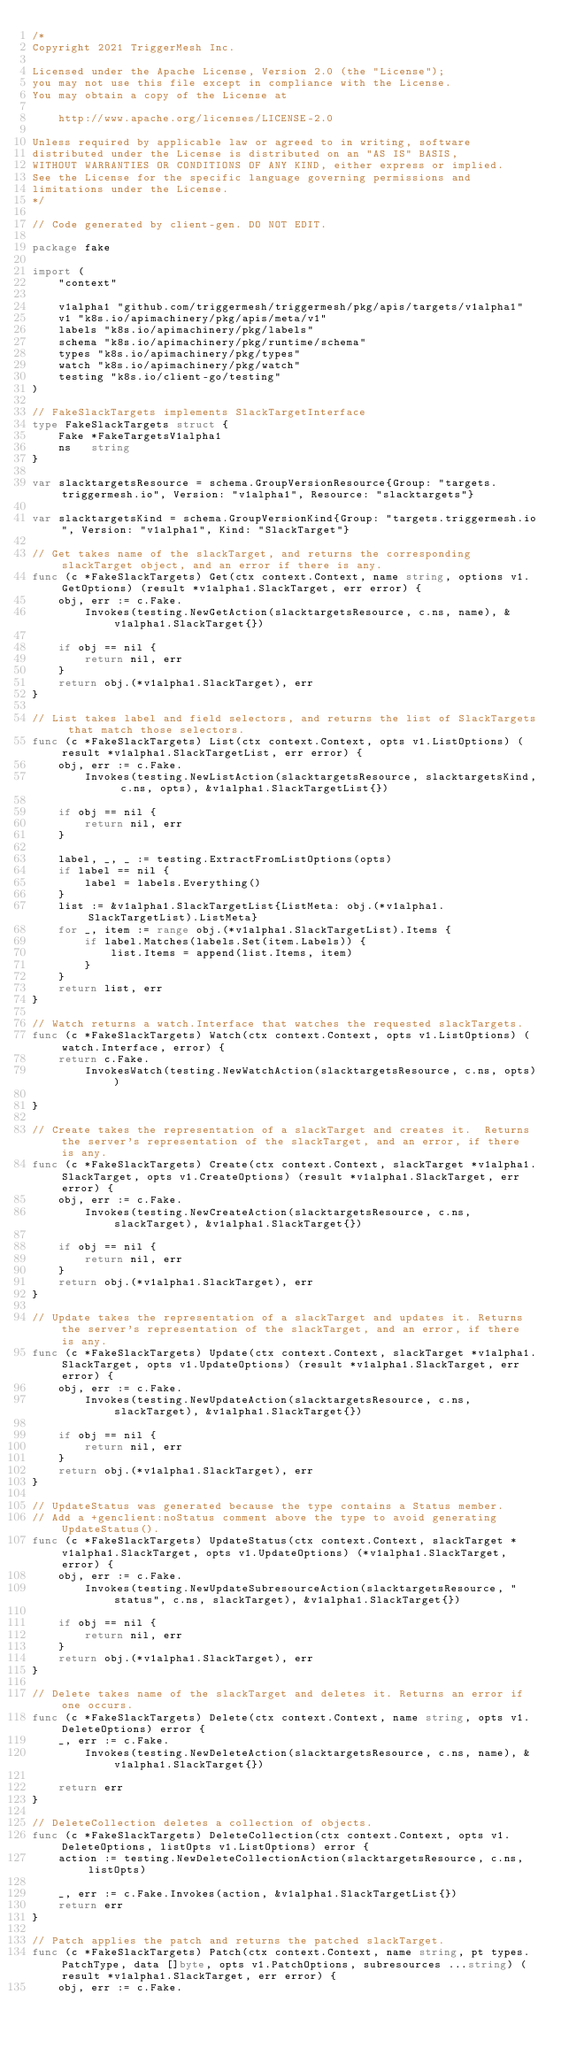Convert code to text. <code><loc_0><loc_0><loc_500><loc_500><_Go_>/*
Copyright 2021 TriggerMesh Inc.

Licensed under the Apache License, Version 2.0 (the "License");
you may not use this file except in compliance with the License.
You may obtain a copy of the License at

    http://www.apache.org/licenses/LICENSE-2.0

Unless required by applicable law or agreed to in writing, software
distributed under the License is distributed on an "AS IS" BASIS,
WITHOUT WARRANTIES OR CONDITIONS OF ANY KIND, either express or implied.
See the License for the specific language governing permissions and
limitations under the License.
*/

// Code generated by client-gen. DO NOT EDIT.

package fake

import (
	"context"

	v1alpha1 "github.com/triggermesh/triggermesh/pkg/apis/targets/v1alpha1"
	v1 "k8s.io/apimachinery/pkg/apis/meta/v1"
	labels "k8s.io/apimachinery/pkg/labels"
	schema "k8s.io/apimachinery/pkg/runtime/schema"
	types "k8s.io/apimachinery/pkg/types"
	watch "k8s.io/apimachinery/pkg/watch"
	testing "k8s.io/client-go/testing"
)

// FakeSlackTargets implements SlackTargetInterface
type FakeSlackTargets struct {
	Fake *FakeTargetsV1alpha1
	ns   string
}

var slacktargetsResource = schema.GroupVersionResource{Group: "targets.triggermesh.io", Version: "v1alpha1", Resource: "slacktargets"}

var slacktargetsKind = schema.GroupVersionKind{Group: "targets.triggermesh.io", Version: "v1alpha1", Kind: "SlackTarget"}

// Get takes name of the slackTarget, and returns the corresponding slackTarget object, and an error if there is any.
func (c *FakeSlackTargets) Get(ctx context.Context, name string, options v1.GetOptions) (result *v1alpha1.SlackTarget, err error) {
	obj, err := c.Fake.
		Invokes(testing.NewGetAction(slacktargetsResource, c.ns, name), &v1alpha1.SlackTarget{})

	if obj == nil {
		return nil, err
	}
	return obj.(*v1alpha1.SlackTarget), err
}

// List takes label and field selectors, and returns the list of SlackTargets that match those selectors.
func (c *FakeSlackTargets) List(ctx context.Context, opts v1.ListOptions) (result *v1alpha1.SlackTargetList, err error) {
	obj, err := c.Fake.
		Invokes(testing.NewListAction(slacktargetsResource, slacktargetsKind, c.ns, opts), &v1alpha1.SlackTargetList{})

	if obj == nil {
		return nil, err
	}

	label, _, _ := testing.ExtractFromListOptions(opts)
	if label == nil {
		label = labels.Everything()
	}
	list := &v1alpha1.SlackTargetList{ListMeta: obj.(*v1alpha1.SlackTargetList).ListMeta}
	for _, item := range obj.(*v1alpha1.SlackTargetList).Items {
		if label.Matches(labels.Set(item.Labels)) {
			list.Items = append(list.Items, item)
		}
	}
	return list, err
}

// Watch returns a watch.Interface that watches the requested slackTargets.
func (c *FakeSlackTargets) Watch(ctx context.Context, opts v1.ListOptions) (watch.Interface, error) {
	return c.Fake.
		InvokesWatch(testing.NewWatchAction(slacktargetsResource, c.ns, opts))

}

// Create takes the representation of a slackTarget and creates it.  Returns the server's representation of the slackTarget, and an error, if there is any.
func (c *FakeSlackTargets) Create(ctx context.Context, slackTarget *v1alpha1.SlackTarget, opts v1.CreateOptions) (result *v1alpha1.SlackTarget, err error) {
	obj, err := c.Fake.
		Invokes(testing.NewCreateAction(slacktargetsResource, c.ns, slackTarget), &v1alpha1.SlackTarget{})

	if obj == nil {
		return nil, err
	}
	return obj.(*v1alpha1.SlackTarget), err
}

// Update takes the representation of a slackTarget and updates it. Returns the server's representation of the slackTarget, and an error, if there is any.
func (c *FakeSlackTargets) Update(ctx context.Context, slackTarget *v1alpha1.SlackTarget, opts v1.UpdateOptions) (result *v1alpha1.SlackTarget, err error) {
	obj, err := c.Fake.
		Invokes(testing.NewUpdateAction(slacktargetsResource, c.ns, slackTarget), &v1alpha1.SlackTarget{})

	if obj == nil {
		return nil, err
	}
	return obj.(*v1alpha1.SlackTarget), err
}

// UpdateStatus was generated because the type contains a Status member.
// Add a +genclient:noStatus comment above the type to avoid generating UpdateStatus().
func (c *FakeSlackTargets) UpdateStatus(ctx context.Context, slackTarget *v1alpha1.SlackTarget, opts v1.UpdateOptions) (*v1alpha1.SlackTarget, error) {
	obj, err := c.Fake.
		Invokes(testing.NewUpdateSubresourceAction(slacktargetsResource, "status", c.ns, slackTarget), &v1alpha1.SlackTarget{})

	if obj == nil {
		return nil, err
	}
	return obj.(*v1alpha1.SlackTarget), err
}

// Delete takes name of the slackTarget and deletes it. Returns an error if one occurs.
func (c *FakeSlackTargets) Delete(ctx context.Context, name string, opts v1.DeleteOptions) error {
	_, err := c.Fake.
		Invokes(testing.NewDeleteAction(slacktargetsResource, c.ns, name), &v1alpha1.SlackTarget{})

	return err
}

// DeleteCollection deletes a collection of objects.
func (c *FakeSlackTargets) DeleteCollection(ctx context.Context, opts v1.DeleteOptions, listOpts v1.ListOptions) error {
	action := testing.NewDeleteCollectionAction(slacktargetsResource, c.ns, listOpts)

	_, err := c.Fake.Invokes(action, &v1alpha1.SlackTargetList{})
	return err
}

// Patch applies the patch and returns the patched slackTarget.
func (c *FakeSlackTargets) Patch(ctx context.Context, name string, pt types.PatchType, data []byte, opts v1.PatchOptions, subresources ...string) (result *v1alpha1.SlackTarget, err error) {
	obj, err := c.Fake.</code> 